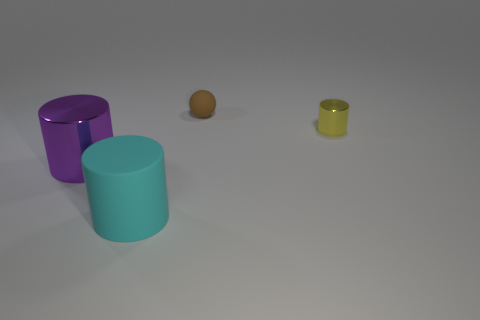Could you describe the lighting in the scene? The lighting in the scene appears to be soft and diffused, coming from above, as indicated by the shadows cast directly underneath each object. There are no harsh shadows or bright spots, which suggests an even and soft light source. 